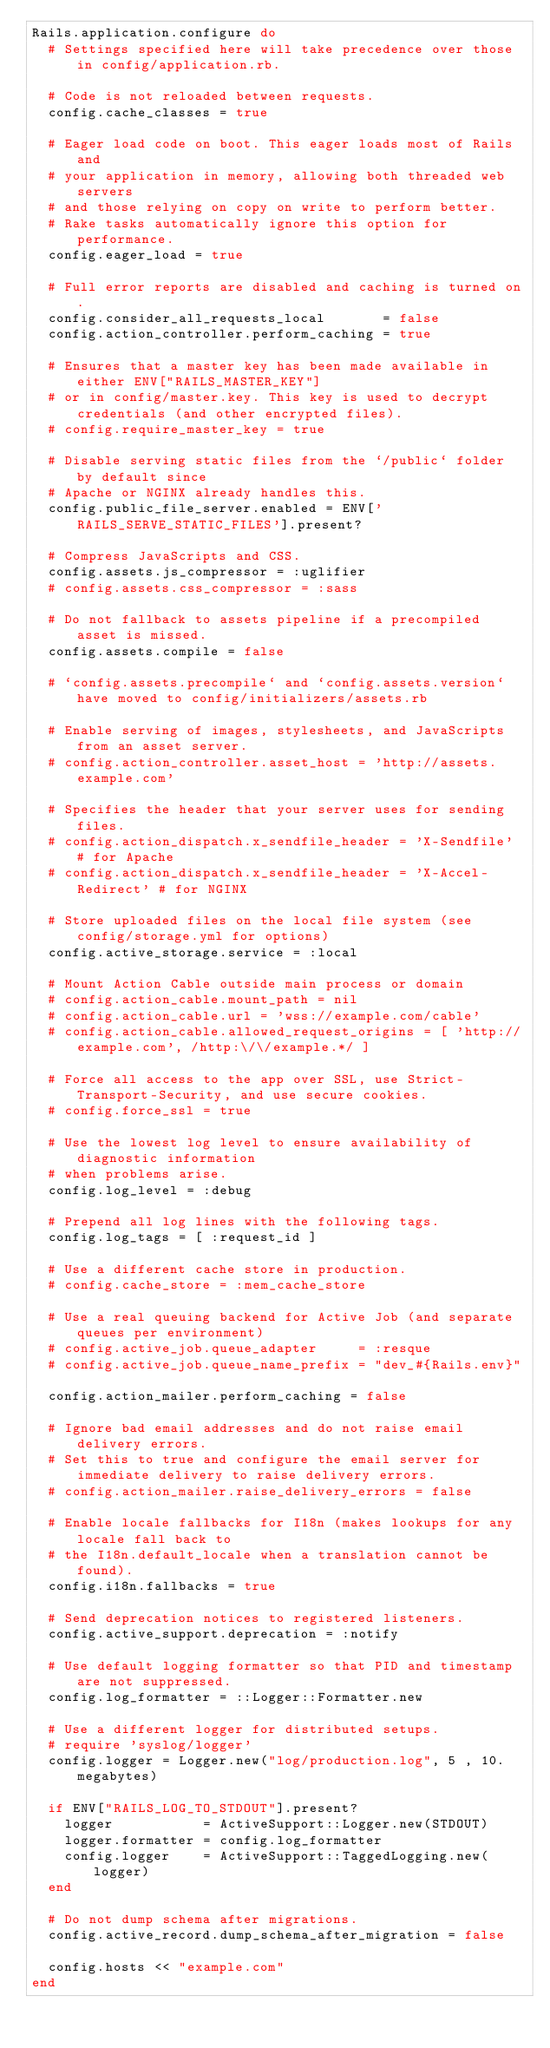Convert code to text. <code><loc_0><loc_0><loc_500><loc_500><_Ruby_>Rails.application.configure do
  # Settings specified here will take precedence over those in config/application.rb.

  # Code is not reloaded between requests.
  config.cache_classes = true

  # Eager load code on boot. This eager loads most of Rails and
  # your application in memory, allowing both threaded web servers
  # and those relying on copy on write to perform better.
  # Rake tasks automatically ignore this option for performance.
  config.eager_load = true

  # Full error reports are disabled and caching is turned on.
  config.consider_all_requests_local       = false
  config.action_controller.perform_caching = true

  # Ensures that a master key has been made available in either ENV["RAILS_MASTER_KEY"]
  # or in config/master.key. This key is used to decrypt credentials (and other encrypted files).
  # config.require_master_key = true

  # Disable serving static files from the `/public` folder by default since
  # Apache or NGINX already handles this.
  config.public_file_server.enabled = ENV['RAILS_SERVE_STATIC_FILES'].present?

  # Compress JavaScripts and CSS.
  config.assets.js_compressor = :uglifier
  # config.assets.css_compressor = :sass

  # Do not fallback to assets pipeline if a precompiled asset is missed.
  config.assets.compile = false

  # `config.assets.precompile` and `config.assets.version` have moved to config/initializers/assets.rb

  # Enable serving of images, stylesheets, and JavaScripts from an asset server.
  # config.action_controller.asset_host = 'http://assets.example.com'

  # Specifies the header that your server uses for sending files.
  # config.action_dispatch.x_sendfile_header = 'X-Sendfile' # for Apache
  # config.action_dispatch.x_sendfile_header = 'X-Accel-Redirect' # for NGINX

  # Store uploaded files on the local file system (see config/storage.yml for options)
  config.active_storage.service = :local

  # Mount Action Cable outside main process or domain
  # config.action_cable.mount_path = nil
  # config.action_cable.url = 'wss://example.com/cable'
  # config.action_cable.allowed_request_origins = [ 'http://example.com', /http:\/\/example.*/ ]

  # Force all access to the app over SSL, use Strict-Transport-Security, and use secure cookies.
  # config.force_ssl = true

  # Use the lowest log level to ensure availability of diagnostic information
  # when problems arise.
  config.log_level = :debug

  # Prepend all log lines with the following tags.
  config.log_tags = [ :request_id ]

  # Use a different cache store in production.
  # config.cache_store = :mem_cache_store

  # Use a real queuing backend for Active Job (and separate queues per environment)
  # config.active_job.queue_adapter     = :resque
  # config.active_job.queue_name_prefix = "dev_#{Rails.env}"

  config.action_mailer.perform_caching = false

  # Ignore bad email addresses and do not raise email delivery errors.
  # Set this to true and configure the email server for immediate delivery to raise delivery errors.
  # config.action_mailer.raise_delivery_errors = false

  # Enable locale fallbacks for I18n (makes lookups for any locale fall back to
  # the I18n.default_locale when a translation cannot be found).
  config.i18n.fallbacks = true

  # Send deprecation notices to registered listeners.
  config.active_support.deprecation = :notify

  # Use default logging formatter so that PID and timestamp are not suppressed.
  config.log_formatter = ::Logger::Formatter.new

  # Use a different logger for distributed setups.
  # require 'syslog/logger'
  config.logger = Logger.new("log/production.log", 5 , 10.megabytes)

  if ENV["RAILS_LOG_TO_STDOUT"].present?
    logger           = ActiveSupport::Logger.new(STDOUT)
    logger.formatter = config.log_formatter
    config.logger    = ActiveSupport::TaggedLogging.new(logger)
  end

  # Do not dump schema after migrations.
  config.active_record.dump_schema_after_migration = false

  config.hosts << "example.com"
end
</code> 